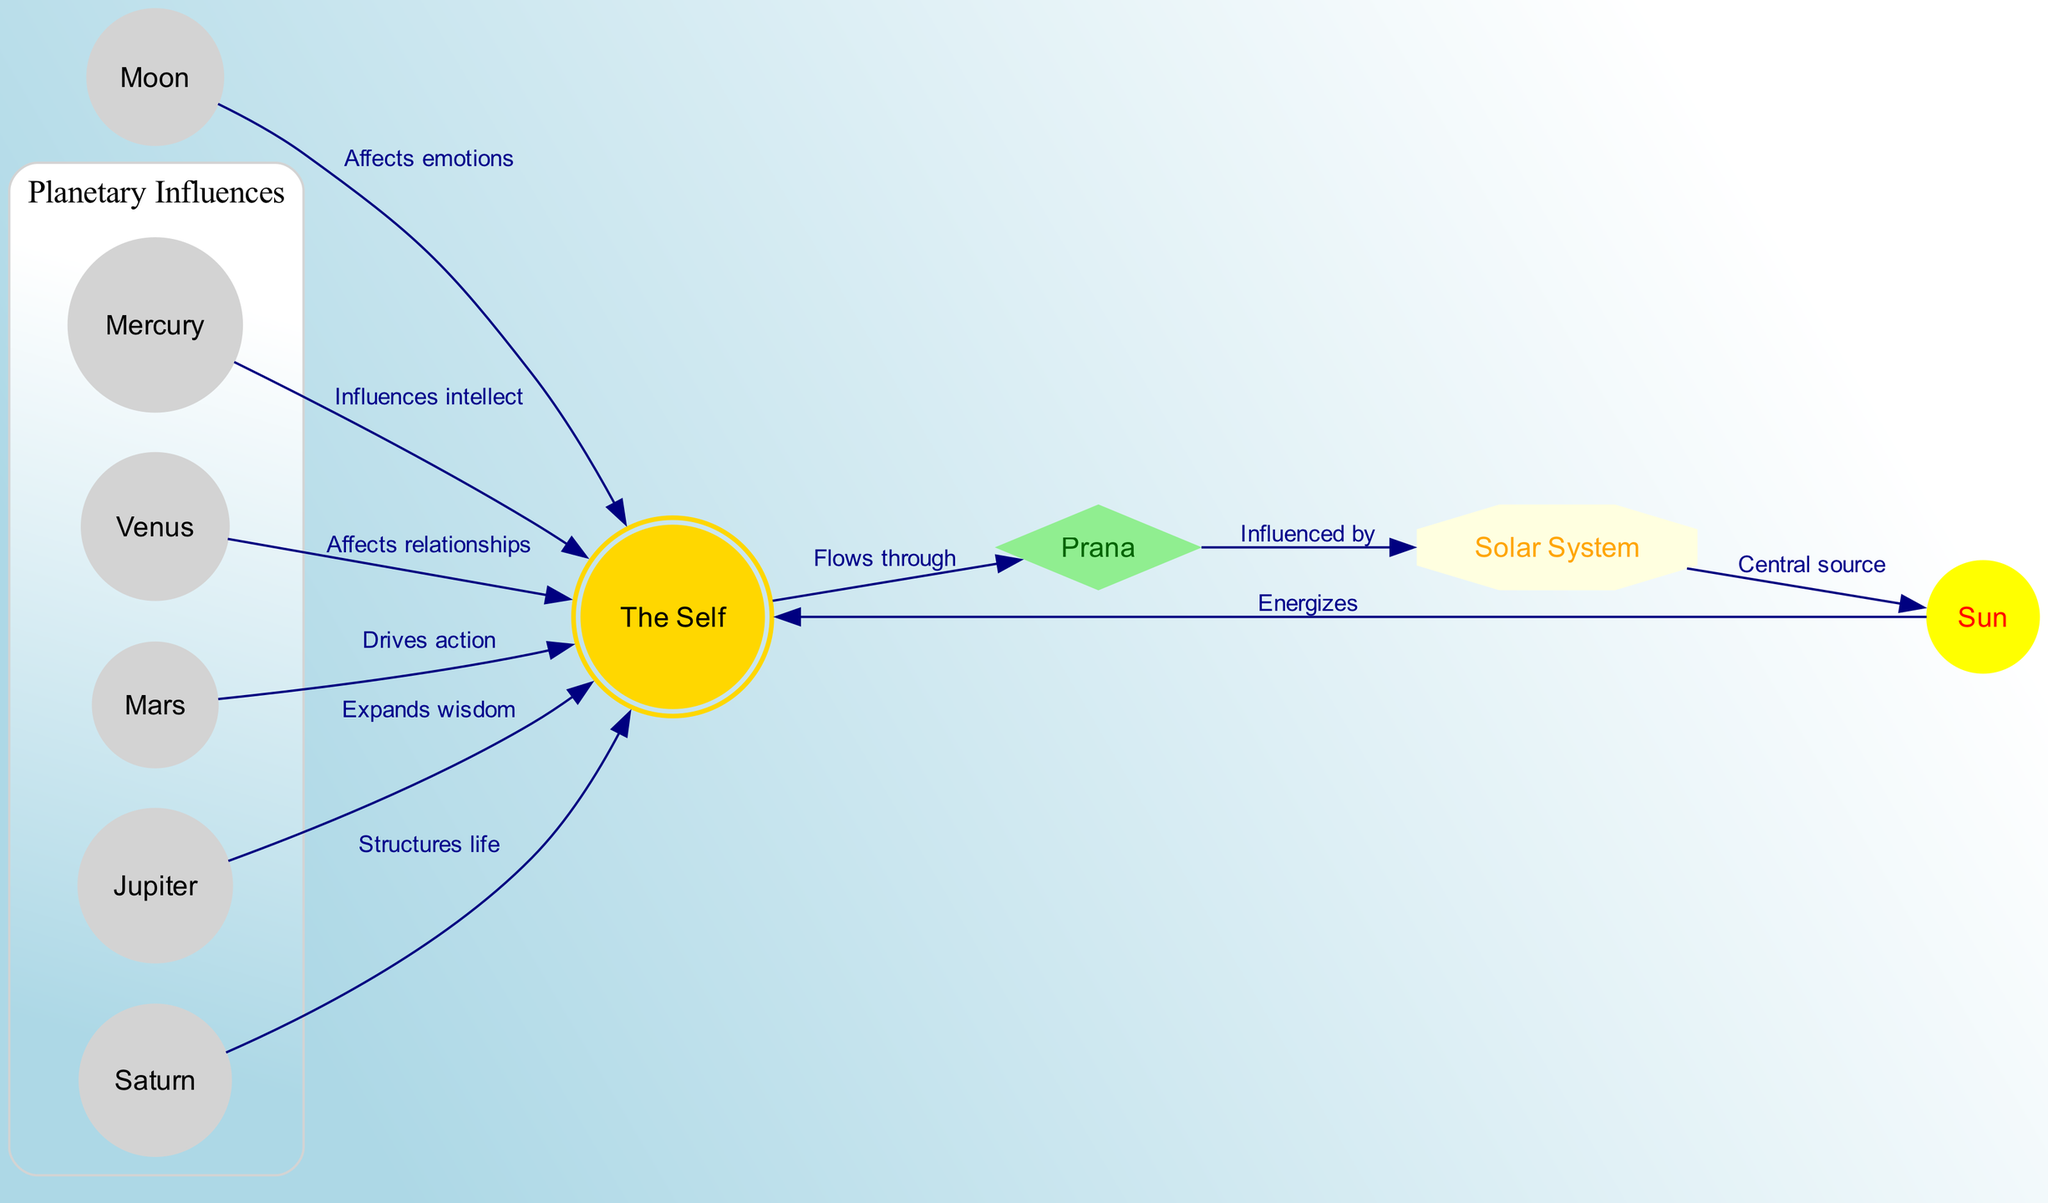What is the main source of Prana in the diagram? The diagram indicates that the Sun serves as the central source of Prana, directly influencing the Self. There’s a specific edge labeled "Central source" from the solar_system to the Sun indicating this relationship.
Answer: Sun How many nodes are present in the diagram? By counting each unique node listed in the data, we find there are a total of 10 nodes, represented by entities such as the Self, Prana, and various celestial bodies.
Answer: 10 Which planet is associated with love and harmony? The diagram identifies Venus as the planet that influences love and harmony, as it is explicitly labeled with a description connecting it to those concepts.
Answer: Venus What is the relationship between the Moon and the Self? According to the diagram, the Moon affects emotional states of the Self. The specific edge labeled "Affects emotions" from the Moon to the Self confirms this connection.
Answer: Affects emotions Which planet is depicted with the diamond shape? In the diagram, the node representing Prana is depicted in a diamond shape, indicating its significance within the flow of energy between the Self and the cosmos.
Answer: Prana How does Mars influence the Self? The diagram shows that Mars drives action, illustrating its influence on desire and initiative as it connects to the Self with the edge labeled "Drives action."
Answer: Drives action What role does Saturn play in relating to the Self? Saturn structures life, according to the diagram. The description provided next to the edge shows that its influence brings discipline, resulting in a connection to the Self.
Answer: Structures life Which node flows into the Solar System? According to the diagram, the Prana flows into the Solar System, as indicated by the edge labeling "Influenced by" from Prana to solar_system.
Answer: Prana How many edges connect the planets directly to the Self? By counting the edges that directly connect the planets (Mercury, Venus, Mars, Jupiter, Saturn) to the Self, there are 5 distinct edges, each representing the influence of a different planet on the Self.
Answer: 5 